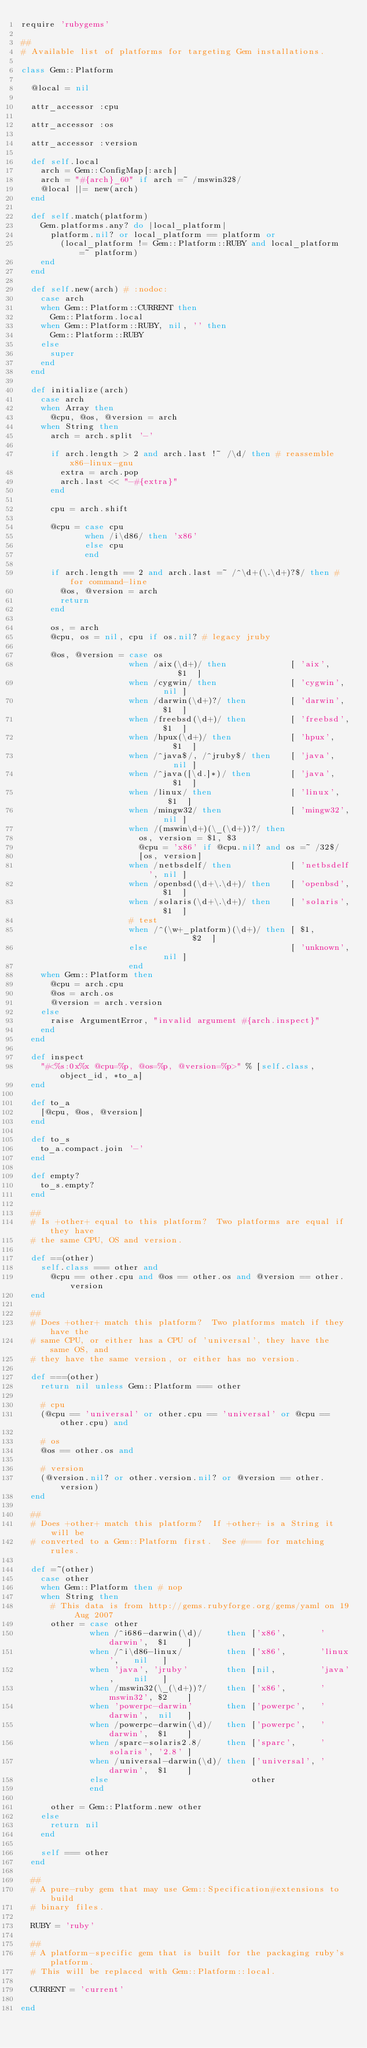<code> <loc_0><loc_0><loc_500><loc_500><_Ruby_>require 'rubygems'

##
# Available list of platforms for targeting Gem installations.

class Gem::Platform

  @local = nil

  attr_accessor :cpu

  attr_accessor :os

  attr_accessor :version

  def self.local
    arch = Gem::ConfigMap[:arch]
    arch = "#{arch}_60" if arch =~ /mswin32$/
    @local ||= new(arch)
  end

  def self.match(platform)
    Gem.platforms.any? do |local_platform|
      platform.nil? or local_platform == platform or
        (local_platform != Gem::Platform::RUBY and local_platform =~ platform)
    end
  end

  def self.new(arch) # :nodoc:
    case arch
    when Gem::Platform::CURRENT then
      Gem::Platform.local
    when Gem::Platform::RUBY, nil, '' then
      Gem::Platform::RUBY
    else
      super
    end
  end

  def initialize(arch)
    case arch
    when Array then
      @cpu, @os, @version = arch
    when String then
      arch = arch.split '-'

      if arch.length > 2 and arch.last !~ /\d/ then # reassemble x86-linux-gnu
        extra = arch.pop
        arch.last << "-#{extra}"
      end

      cpu = arch.shift

      @cpu = case cpu
             when /i\d86/ then 'x86'
             else cpu
             end

      if arch.length == 2 and arch.last =~ /^\d+(\.\d+)?$/ then # for command-line
        @os, @version = arch
        return
      end

      os, = arch
      @cpu, os = nil, cpu if os.nil? # legacy jruby

      @os, @version = case os
                      when /aix(\d+)/ then             [ 'aix',       $1  ]
                      when /cygwin/ then               [ 'cygwin',    nil ]
                      when /darwin(\d+)?/ then         [ 'darwin',    $1  ]
                      when /freebsd(\d+)/ then         [ 'freebsd',   $1  ]
                      when /hpux(\d+)/ then            [ 'hpux',      $1  ]
                      when /^java$/, /^jruby$/ then    [ 'java',      nil ]
                      when /^java([\d.]*)/ then        [ 'java',      $1  ]
                      when /linux/ then                [ 'linux',     $1  ]
                      when /mingw32/ then              [ 'mingw32',   nil ]
                      when /(mswin\d+)(\_(\d+))?/ then
                        os, version = $1, $3
                        @cpu = 'x86' if @cpu.nil? and os =~ /32$/
                        [os, version]
                      when /netbsdelf/ then            [ 'netbsdelf', nil ]
                      when /openbsd(\d+\.\d+)/ then    [ 'openbsd',   $1  ]
                      when /solaris(\d+\.\d+)/ then    [ 'solaris',   $1  ]
                      # test
                      when /^(\w+_platform)(\d+)/ then [ $1,          $2  ]
                      else                             [ 'unknown',   nil ]
                      end
    when Gem::Platform then
      @cpu = arch.cpu
      @os = arch.os
      @version = arch.version
    else
      raise ArgumentError, "invalid argument #{arch.inspect}"
    end
  end

  def inspect
    "#<%s:0x%x @cpu=%p, @os=%p, @version=%p>" % [self.class, object_id, *to_a]
  end

  def to_a
    [@cpu, @os, @version]
  end

  def to_s
    to_a.compact.join '-'
  end
  
  def empty?
    to_s.empty?
  end

  ##
  # Is +other+ equal to this platform?  Two platforms are equal if they have
  # the same CPU, OS and version.

  def ==(other)
    self.class === other and
      @cpu == other.cpu and @os == other.os and @version == other.version
  end

  ##
  # Does +other+ match this platform?  Two platforms match if they have the
  # same CPU, or either has a CPU of 'universal', they have the same OS, and
  # they have the same version, or either has no version.

  def ===(other)
    return nil unless Gem::Platform === other

    # cpu
    (@cpu == 'universal' or other.cpu == 'universal' or @cpu == other.cpu) and

    # os
    @os == other.os and

    # version
    (@version.nil? or other.version.nil? or @version == other.version)
  end

  ##
  # Does +other+ match this platform?  If +other+ is a String it will be
  # converted to a Gem::Platform first.  See #=== for matching rules.

  def =~(other)
    case other
    when Gem::Platform then # nop
    when String then
      # This data is from http://gems.rubyforge.org/gems/yaml on 19 Aug 2007
      other = case other
              when /^i686-darwin(\d)/     then ['x86',       'darwin',  $1    ]
              when /^i\d86-linux/         then ['x86',       'linux',   nil   ]
              when 'java', 'jruby'        then [nil,         'java',    nil   ]
              when /mswin32(\_(\d+))?/    then ['x86',       'mswin32', $2    ]
              when 'powerpc-darwin'       then ['powerpc',   'darwin',  nil   ]
              when /powerpc-darwin(\d)/   then ['powerpc',   'darwin',  $1    ]
              when /sparc-solaris2.8/     then ['sparc',     'solaris', '2.8' ]
              when /universal-darwin(\d)/ then ['universal', 'darwin',  $1    ]
              else                             other
              end

      other = Gem::Platform.new other
    else
      return nil
    end

    self === other
  end

  ##
  # A pure-ruby gem that may use Gem::Specification#extensions to build
  # binary files.

  RUBY = 'ruby'

  ##
  # A platform-specific gem that is built for the packaging ruby's platform.
  # This will be replaced with Gem::Platform::local.

  CURRENT = 'current'

end

</code> 